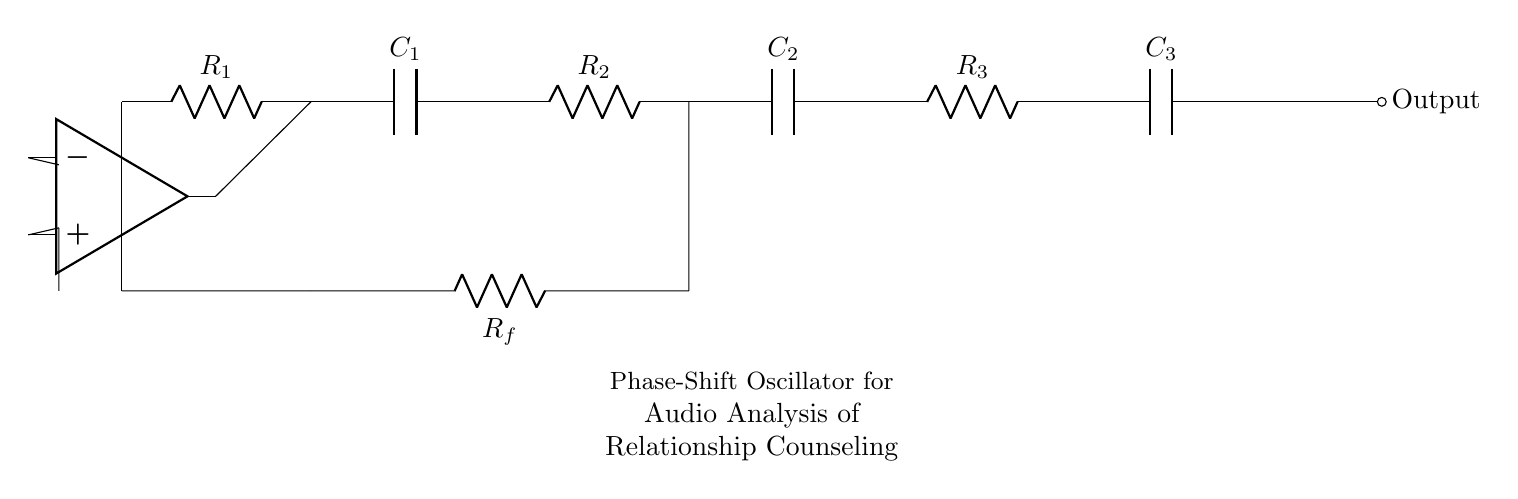What is the output of the circuit? The output is a sine wave generated by the phase-shift oscillator circuit. This type of oscillator is designed to produce continuous oscillations, specifically sine waves, which are typically observed at the output terminal as the signal flows through the circuit.
Answer: Sine wave How many resistors are in the circuit? There are four resistors shown in the circuit diagram, labeled R1, R2, R3, and Rf. By counting the labeled components, we can identify them clearly as part of the circuit configuration.
Answer: Four What is the role of the operational amplifier? The operational amplifier functions as the active component that amplifies the phase-shifted signals from the resistors and capacitors, creating the necessary feedback required for oscillation. It helps in maintaining the oscillation by providing gain and phase shift to the output signal.
Answer: Amplification What is the total number of capacitors in the circuit? The circuit contains three capacitors, indicated as C1, C2, and C3. By examining the diagram, we can easily identify and count the distinct capacitor symbols present.
Answer: Three What phase shift does each stage provide? Each stage in this phase-shift oscillator typically provides a phase shift of 60 degrees, meaning that with three stages, they collectively contribute a total phase shift of 180 degrees. This is essential for sustaining the oscillation condition in the circuit.
Answer: Sixty degrees Which component is used for feedback in the circuit? The feedback is provided through the resistor labeled Rf in the circuit. This resistor connects the output of the operational amplifier back to the input, allowing a portion of the output signal to influence the input to maintain oscillation.
Answer: Rf 